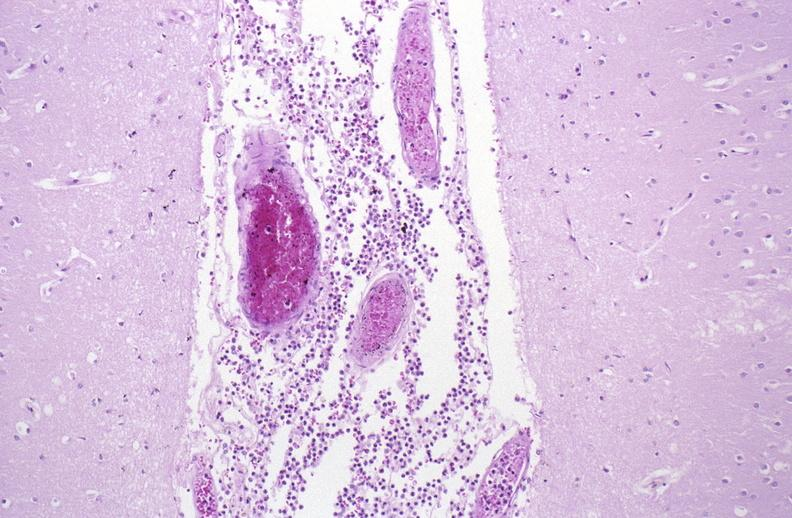what does this image show?
Answer the question using a single word or phrase. Bacterial meningitis 